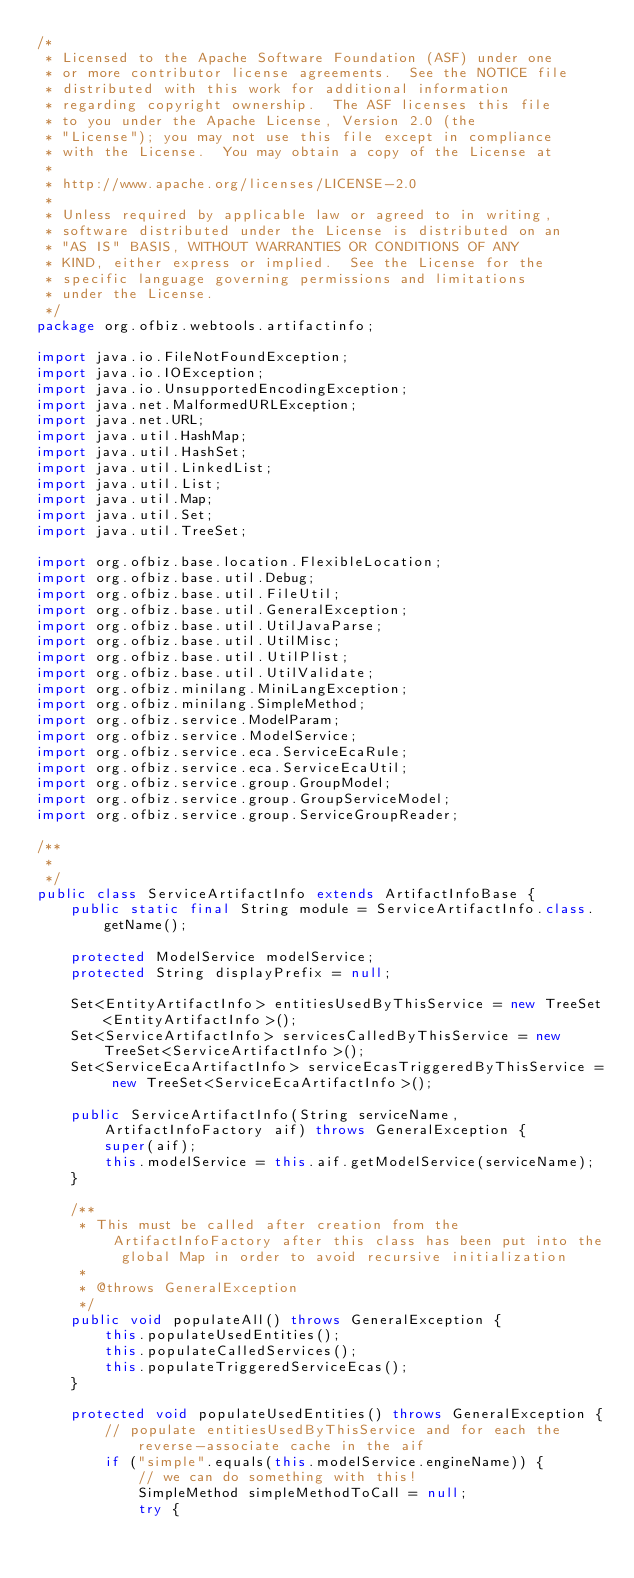<code> <loc_0><loc_0><loc_500><loc_500><_Java_>/*
 * Licensed to the Apache Software Foundation (ASF) under one
 * or more contributor license agreements.  See the NOTICE file
 * distributed with this work for additional information
 * regarding copyright ownership.  The ASF licenses this file
 * to you under the Apache License, Version 2.0 (the
 * "License"); you may not use this file except in compliance
 * with the License.  You may obtain a copy of the License at
 *
 * http://www.apache.org/licenses/LICENSE-2.0
 *
 * Unless required by applicable law or agreed to in writing,
 * software distributed under the License is distributed on an
 * "AS IS" BASIS, WITHOUT WARRANTIES OR CONDITIONS OF ANY
 * KIND, either express or implied.  See the License for the
 * specific language governing permissions and limitations
 * under the License.
 */
package org.ofbiz.webtools.artifactinfo;

import java.io.FileNotFoundException;
import java.io.IOException;
import java.io.UnsupportedEncodingException;
import java.net.MalformedURLException;
import java.net.URL;
import java.util.HashMap;
import java.util.HashSet;
import java.util.LinkedList;
import java.util.List;
import java.util.Map;
import java.util.Set;
import java.util.TreeSet;

import org.ofbiz.base.location.FlexibleLocation;
import org.ofbiz.base.util.Debug;
import org.ofbiz.base.util.FileUtil;
import org.ofbiz.base.util.GeneralException;
import org.ofbiz.base.util.UtilJavaParse;
import org.ofbiz.base.util.UtilMisc;
import org.ofbiz.base.util.UtilPlist;
import org.ofbiz.base.util.UtilValidate;
import org.ofbiz.minilang.MiniLangException;
import org.ofbiz.minilang.SimpleMethod;
import org.ofbiz.service.ModelParam;
import org.ofbiz.service.ModelService;
import org.ofbiz.service.eca.ServiceEcaRule;
import org.ofbiz.service.eca.ServiceEcaUtil;
import org.ofbiz.service.group.GroupModel;
import org.ofbiz.service.group.GroupServiceModel;
import org.ofbiz.service.group.ServiceGroupReader;

/**
 *
 */
public class ServiceArtifactInfo extends ArtifactInfoBase {
    public static final String module = ServiceArtifactInfo.class.getName();

    protected ModelService modelService;
    protected String displayPrefix = null;

    Set<EntityArtifactInfo> entitiesUsedByThisService = new TreeSet<EntityArtifactInfo>();
    Set<ServiceArtifactInfo> servicesCalledByThisService = new TreeSet<ServiceArtifactInfo>();
    Set<ServiceEcaArtifactInfo> serviceEcasTriggeredByThisService = new TreeSet<ServiceEcaArtifactInfo>();

    public ServiceArtifactInfo(String serviceName, ArtifactInfoFactory aif) throws GeneralException {
        super(aif);
        this.modelService = this.aif.getModelService(serviceName);
    }

    /**
     * This must be called after creation from the ArtifactInfoFactory after this class has been put into the global Map in order to avoid recursive initialization
     *
     * @throws GeneralException
     */
    public void populateAll() throws GeneralException {
        this.populateUsedEntities();
        this.populateCalledServices();
        this.populateTriggeredServiceEcas();
    }

    protected void populateUsedEntities() throws GeneralException {
        // populate entitiesUsedByThisService and for each the reverse-associate cache in the aif
        if ("simple".equals(this.modelService.engineName)) {
            // we can do something with this!
            SimpleMethod simpleMethodToCall = null;
            try {</code> 